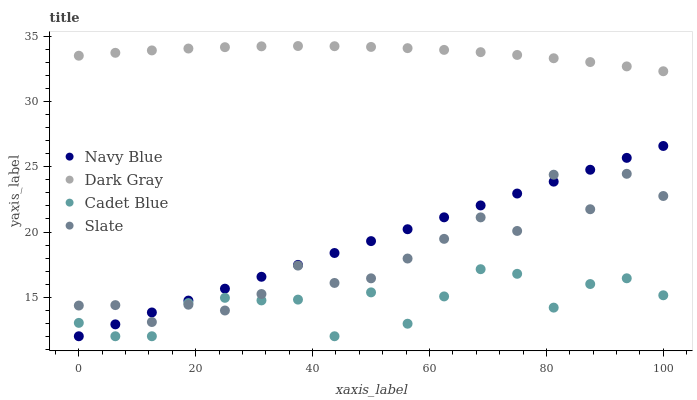Does Cadet Blue have the minimum area under the curve?
Answer yes or no. Yes. Does Dark Gray have the maximum area under the curve?
Answer yes or no. Yes. Does Navy Blue have the minimum area under the curve?
Answer yes or no. No. Does Navy Blue have the maximum area under the curve?
Answer yes or no. No. Is Navy Blue the smoothest?
Answer yes or no. Yes. Is Slate the roughest?
Answer yes or no. Yes. Is Slate the smoothest?
Answer yes or no. No. Is Navy Blue the roughest?
Answer yes or no. No. Does Navy Blue have the lowest value?
Answer yes or no. Yes. Does Slate have the lowest value?
Answer yes or no. No. Does Dark Gray have the highest value?
Answer yes or no. Yes. Does Navy Blue have the highest value?
Answer yes or no. No. Is Slate less than Dark Gray?
Answer yes or no. Yes. Is Dark Gray greater than Slate?
Answer yes or no. Yes. Does Slate intersect Navy Blue?
Answer yes or no. Yes. Is Slate less than Navy Blue?
Answer yes or no. No. Is Slate greater than Navy Blue?
Answer yes or no. No. Does Slate intersect Dark Gray?
Answer yes or no. No. 